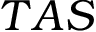<formula> <loc_0><loc_0><loc_500><loc_500>T A S</formula> 